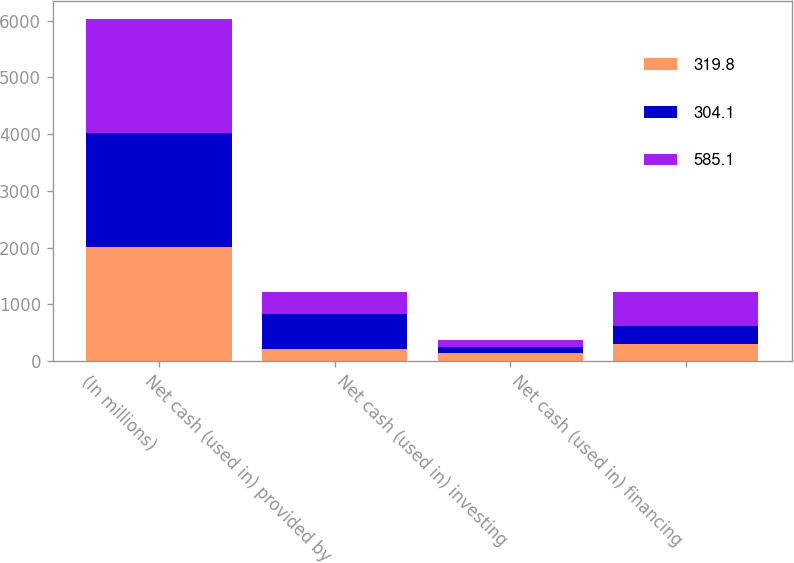<chart> <loc_0><loc_0><loc_500><loc_500><stacked_bar_chart><ecel><fcel>(In millions)<fcel>Net cash (used in) provided by<fcel>Net cash (used in) investing<fcel>Net cash (used in) financing<nl><fcel>319.8<fcel>2014<fcel>201.9<fcel>141.5<fcel>304.1<nl><fcel>304.1<fcel>2013<fcel>624.8<fcel>105.5<fcel>319.8<nl><fcel>585.1<fcel>2012<fcel>394.2<fcel>114.9<fcel>585.1<nl></chart> 